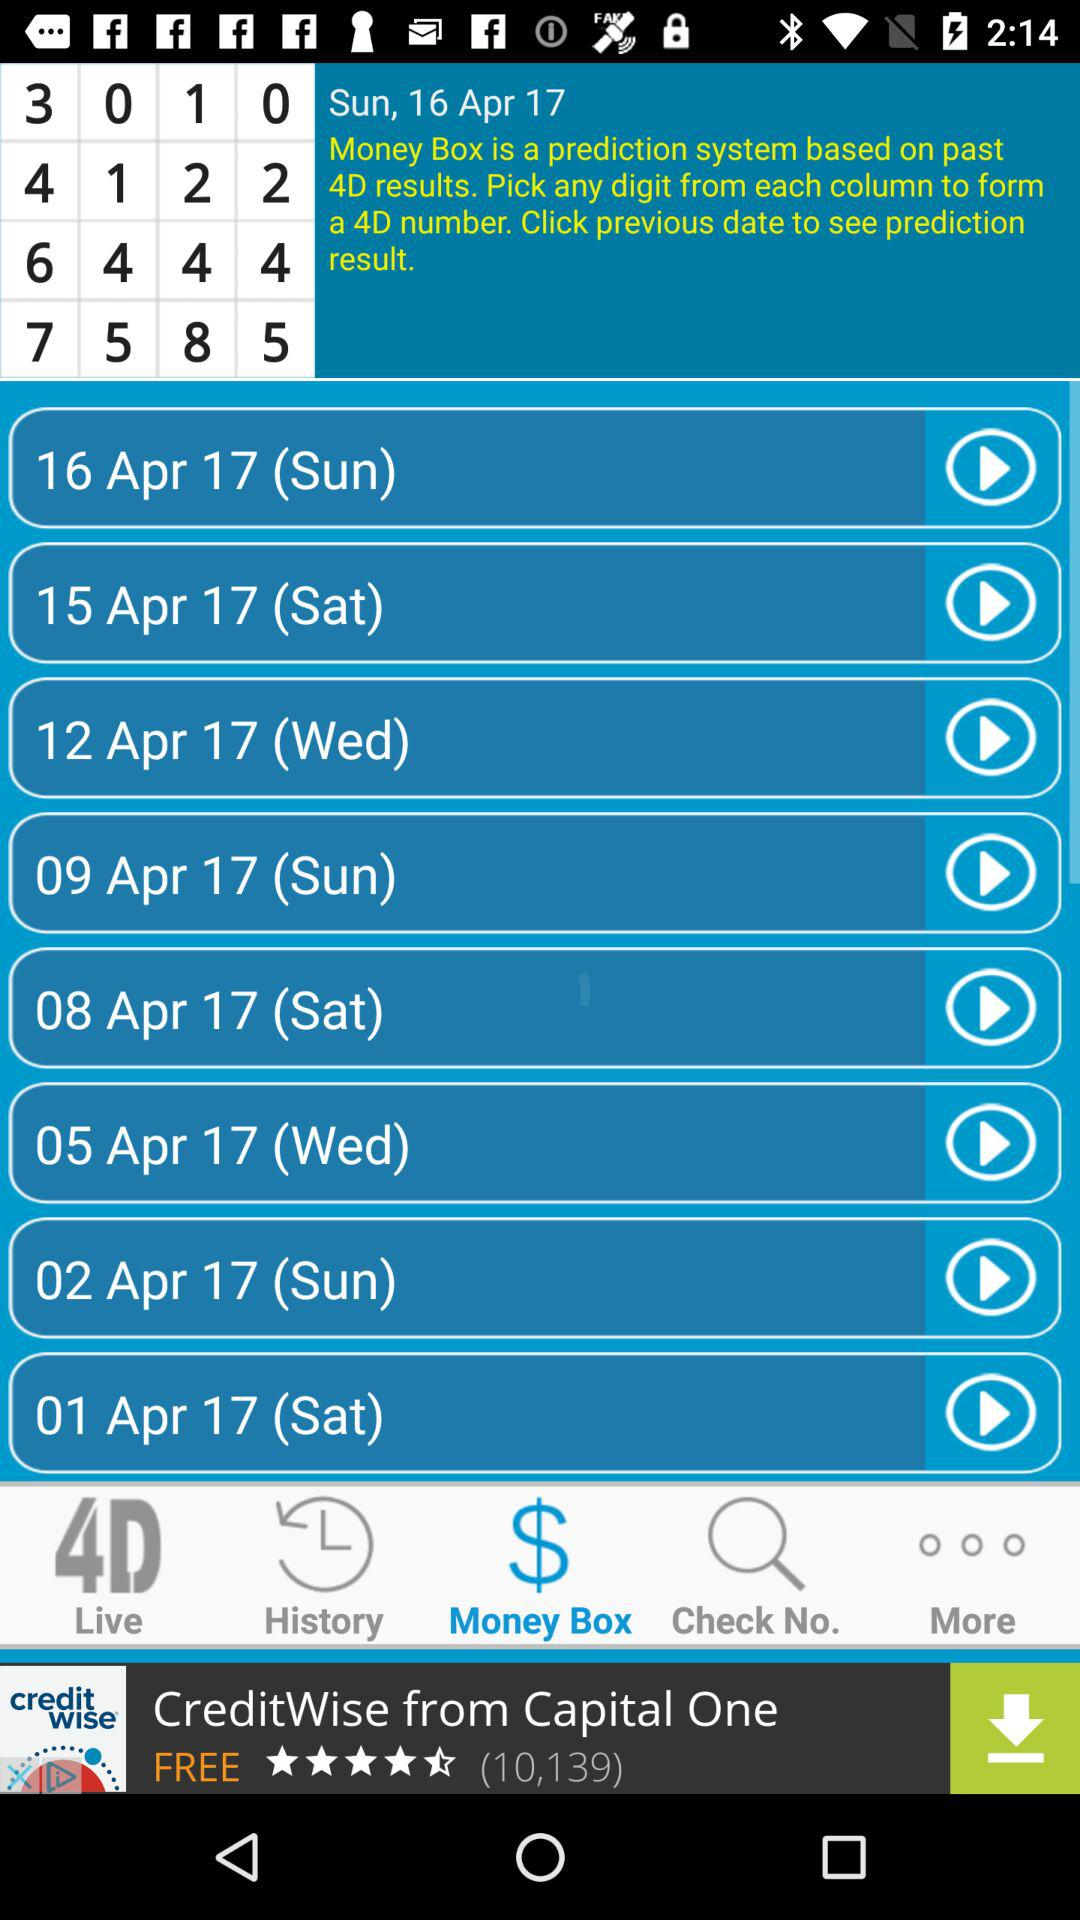Which tab has been selected? The selected tab is "Money Box". 